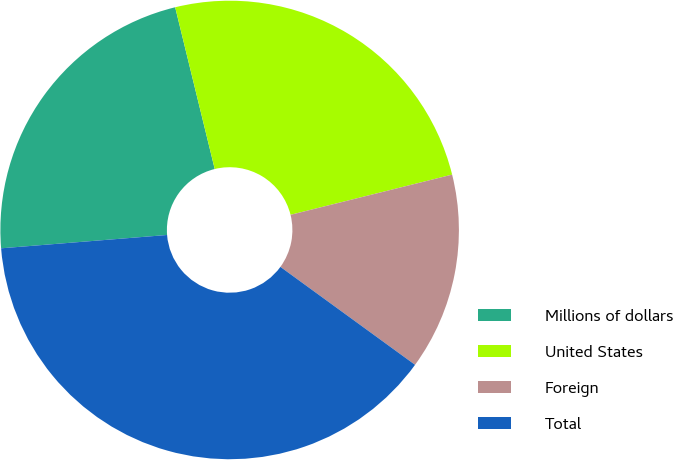Convert chart to OTSL. <chart><loc_0><loc_0><loc_500><loc_500><pie_chart><fcel>Millions of dollars<fcel>United States<fcel>Foreign<fcel>Total<nl><fcel>22.46%<fcel>24.94%<fcel>13.89%<fcel>38.72%<nl></chart> 